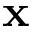Convert formula to latex. <formula><loc_0><loc_0><loc_500><loc_500>x</formula> 